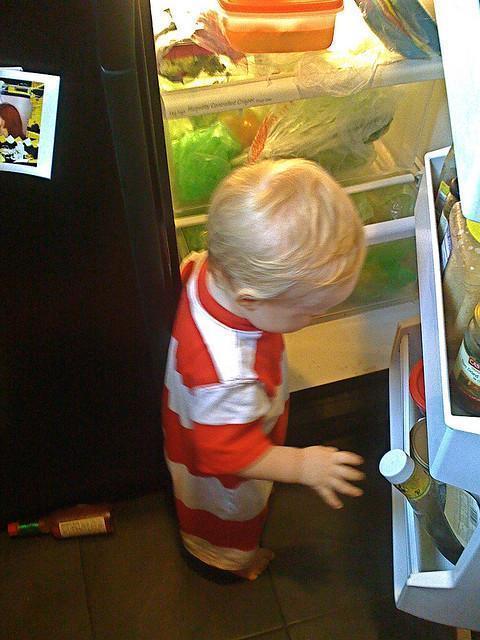What color outfit is the child wearing?
Indicate the correct response by choosing from the four available options to answer the question.
Options: Red, pink, blue, green. Red. 